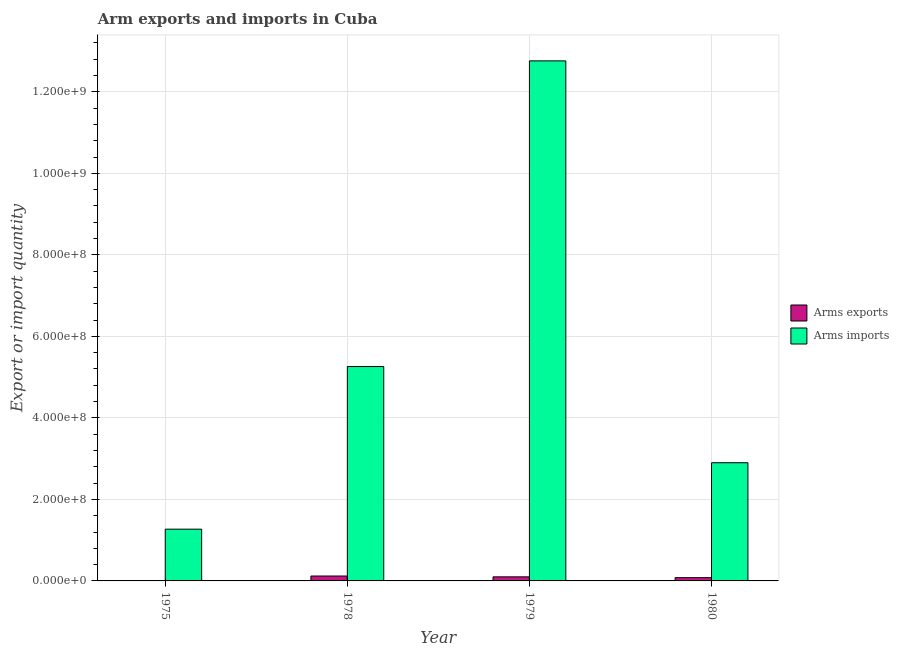How many groups of bars are there?
Keep it short and to the point. 4. Are the number of bars per tick equal to the number of legend labels?
Provide a succinct answer. Yes. Are the number of bars on each tick of the X-axis equal?
Provide a short and direct response. Yes. What is the label of the 1st group of bars from the left?
Keep it short and to the point. 1975. In how many cases, is the number of bars for a given year not equal to the number of legend labels?
Your response must be concise. 0. What is the arms imports in 1975?
Your answer should be compact. 1.27e+08. Across all years, what is the maximum arms imports?
Offer a terse response. 1.28e+09. Across all years, what is the minimum arms exports?
Make the answer very short. 1.00e+06. In which year was the arms imports maximum?
Keep it short and to the point. 1979. In which year was the arms exports minimum?
Keep it short and to the point. 1975. What is the total arms exports in the graph?
Provide a succinct answer. 3.10e+07. What is the difference between the arms imports in 1975 and that in 1980?
Your answer should be compact. -1.63e+08. What is the difference between the arms imports in 1979 and the arms exports in 1980?
Provide a succinct answer. 9.86e+08. What is the average arms imports per year?
Offer a terse response. 5.55e+08. What is the ratio of the arms exports in 1975 to that in 1978?
Provide a succinct answer. 0.08. Is the arms exports in 1975 less than that in 1978?
Your answer should be very brief. Yes. Is the difference between the arms exports in 1978 and 1979 greater than the difference between the arms imports in 1978 and 1979?
Provide a succinct answer. No. What is the difference between the highest and the second highest arms imports?
Give a very brief answer. 7.50e+08. What is the difference between the highest and the lowest arms imports?
Your answer should be compact. 1.15e+09. What does the 2nd bar from the left in 1979 represents?
Offer a terse response. Arms imports. What does the 2nd bar from the right in 1980 represents?
Keep it short and to the point. Arms exports. How many bars are there?
Your answer should be very brief. 8. Are all the bars in the graph horizontal?
Give a very brief answer. No. How many years are there in the graph?
Your response must be concise. 4. Does the graph contain grids?
Provide a succinct answer. Yes. Where does the legend appear in the graph?
Provide a succinct answer. Center right. How many legend labels are there?
Provide a short and direct response. 2. How are the legend labels stacked?
Provide a succinct answer. Vertical. What is the title of the graph?
Offer a very short reply. Arm exports and imports in Cuba. What is the label or title of the Y-axis?
Provide a short and direct response. Export or import quantity. What is the Export or import quantity in Arms imports in 1975?
Ensure brevity in your answer.  1.27e+08. What is the Export or import quantity in Arms imports in 1978?
Provide a short and direct response. 5.26e+08. What is the Export or import quantity of Arms exports in 1979?
Your answer should be compact. 1.00e+07. What is the Export or import quantity of Arms imports in 1979?
Your answer should be very brief. 1.28e+09. What is the Export or import quantity in Arms imports in 1980?
Your response must be concise. 2.90e+08. Across all years, what is the maximum Export or import quantity in Arms exports?
Your answer should be very brief. 1.20e+07. Across all years, what is the maximum Export or import quantity of Arms imports?
Your answer should be very brief. 1.28e+09. Across all years, what is the minimum Export or import quantity in Arms exports?
Your answer should be very brief. 1.00e+06. Across all years, what is the minimum Export or import quantity in Arms imports?
Offer a terse response. 1.27e+08. What is the total Export or import quantity of Arms exports in the graph?
Your answer should be very brief. 3.10e+07. What is the total Export or import quantity in Arms imports in the graph?
Keep it short and to the point. 2.22e+09. What is the difference between the Export or import quantity of Arms exports in 1975 and that in 1978?
Your answer should be compact. -1.10e+07. What is the difference between the Export or import quantity of Arms imports in 1975 and that in 1978?
Provide a short and direct response. -3.99e+08. What is the difference between the Export or import quantity of Arms exports in 1975 and that in 1979?
Offer a terse response. -9.00e+06. What is the difference between the Export or import quantity of Arms imports in 1975 and that in 1979?
Your answer should be compact. -1.15e+09. What is the difference between the Export or import quantity in Arms exports in 1975 and that in 1980?
Your answer should be very brief. -7.00e+06. What is the difference between the Export or import quantity of Arms imports in 1975 and that in 1980?
Your answer should be very brief. -1.63e+08. What is the difference between the Export or import quantity in Arms exports in 1978 and that in 1979?
Ensure brevity in your answer.  2.00e+06. What is the difference between the Export or import quantity in Arms imports in 1978 and that in 1979?
Your response must be concise. -7.50e+08. What is the difference between the Export or import quantity of Arms imports in 1978 and that in 1980?
Your answer should be compact. 2.36e+08. What is the difference between the Export or import quantity of Arms imports in 1979 and that in 1980?
Offer a terse response. 9.86e+08. What is the difference between the Export or import quantity of Arms exports in 1975 and the Export or import quantity of Arms imports in 1978?
Your response must be concise. -5.25e+08. What is the difference between the Export or import quantity in Arms exports in 1975 and the Export or import quantity in Arms imports in 1979?
Ensure brevity in your answer.  -1.28e+09. What is the difference between the Export or import quantity in Arms exports in 1975 and the Export or import quantity in Arms imports in 1980?
Ensure brevity in your answer.  -2.89e+08. What is the difference between the Export or import quantity in Arms exports in 1978 and the Export or import quantity in Arms imports in 1979?
Provide a succinct answer. -1.26e+09. What is the difference between the Export or import quantity in Arms exports in 1978 and the Export or import quantity in Arms imports in 1980?
Make the answer very short. -2.78e+08. What is the difference between the Export or import quantity of Arms exports in 1979 and the Export or import quantity of Arms imports in 1980?
Provide a succinct answer. -2.80e+08. What is the average Export or import quantity of Arms exports per year?
Give a very brief answer. 7.75e+06. What is the average Export or import quantity in Arms imports per year?
Your answer should be compact. 5.55e+08. In the year 1975, what is the difference between the Export or import quantity in Arms exports and Export or import quantity in Arms imports?
Make the answer very short. -1.26e+08. In the year 1978, what is the difference between the Export or import quantity of Arms exports and Export or import quantity of Arms imports?
Give a very brief answer. -5.14e+08. In the year 1979, what is the difference between the Export or import quantity in Arms exports and Export or import quantity in Arms imports?
Keep it short and to the point. -1.27e+09. In the year 1980, what is the difference between the Export or import quantity in Arms exports and Export or import quantity in Arms imports?
Your answer should be very brief. -2.82e+08. What is the ratio of the Export or import quantity in Arms exports in 1975 to that in 1978?
Keep it short and to the point. 0.08. What is the ratio of the Export or import quantity in Arms imports in 1975 to that in 1978?
Keep it short and to the point. 0.24. What is the ratio of the Export or import quantity of Arms imports in 1975 to that in 1979?
Offer a very short reply. 0.1. What is the ratio of the Export or import quantity of Arms exports in 1975 to that in 1980?
Your response must be concise. 0.12. What is the ratio of the Export or import quantity in Arms imports in 1975 to that in 1980?
Keep it short and to the point. 0.44. What is the ratio of the Export or import quantity in Arms exports in 1978 to that in 1979?
Keep it short and to the point. 1.2. What is the ratio of the Export or import quantity in Arms imports in 1978 to that in 1979?
Keep it short and to the point. 0.41. What is the ratio of the Export or import quantity in Arms exports in 1978 to that in 1980?
Offer a terse response. 1.5. What is the ratio of the Export or import quantity of Arms imports in 1978 to that in 1980?
Your answer should be compact. 1.81. What is the ratio of the Export or import quantity in Arms exports in 1979 to that in 1980?
Provide a short and direct response. 1.25. What is the difference between the highest and the second highest Export or import quantity in Arms imports?
Your response must be concise. 7.50e+08. What is the difference between the highest and the lowest Export or import quantity of Arms exports?
Offer a terse response. 1.10e+07. What is the difference between the highest and the lowest Export or import quantity of Arms imports?
Your response must be concise. 1.15e+09. 